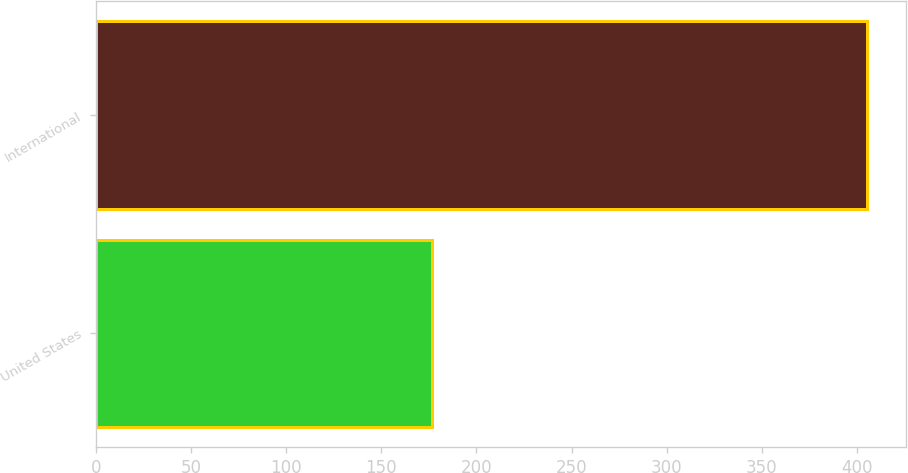Convert chart. <chart><loc_0><loc_0><loc_500><loc_500><bar_chart><fcel>United States<fcel>International<nl><fcel>176.5<fcel>405.5<nl></chart> 